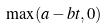<formula> <loc_0><loc_0><loc_500><loc_500>\max ( a - b t , 0 )</formula> 